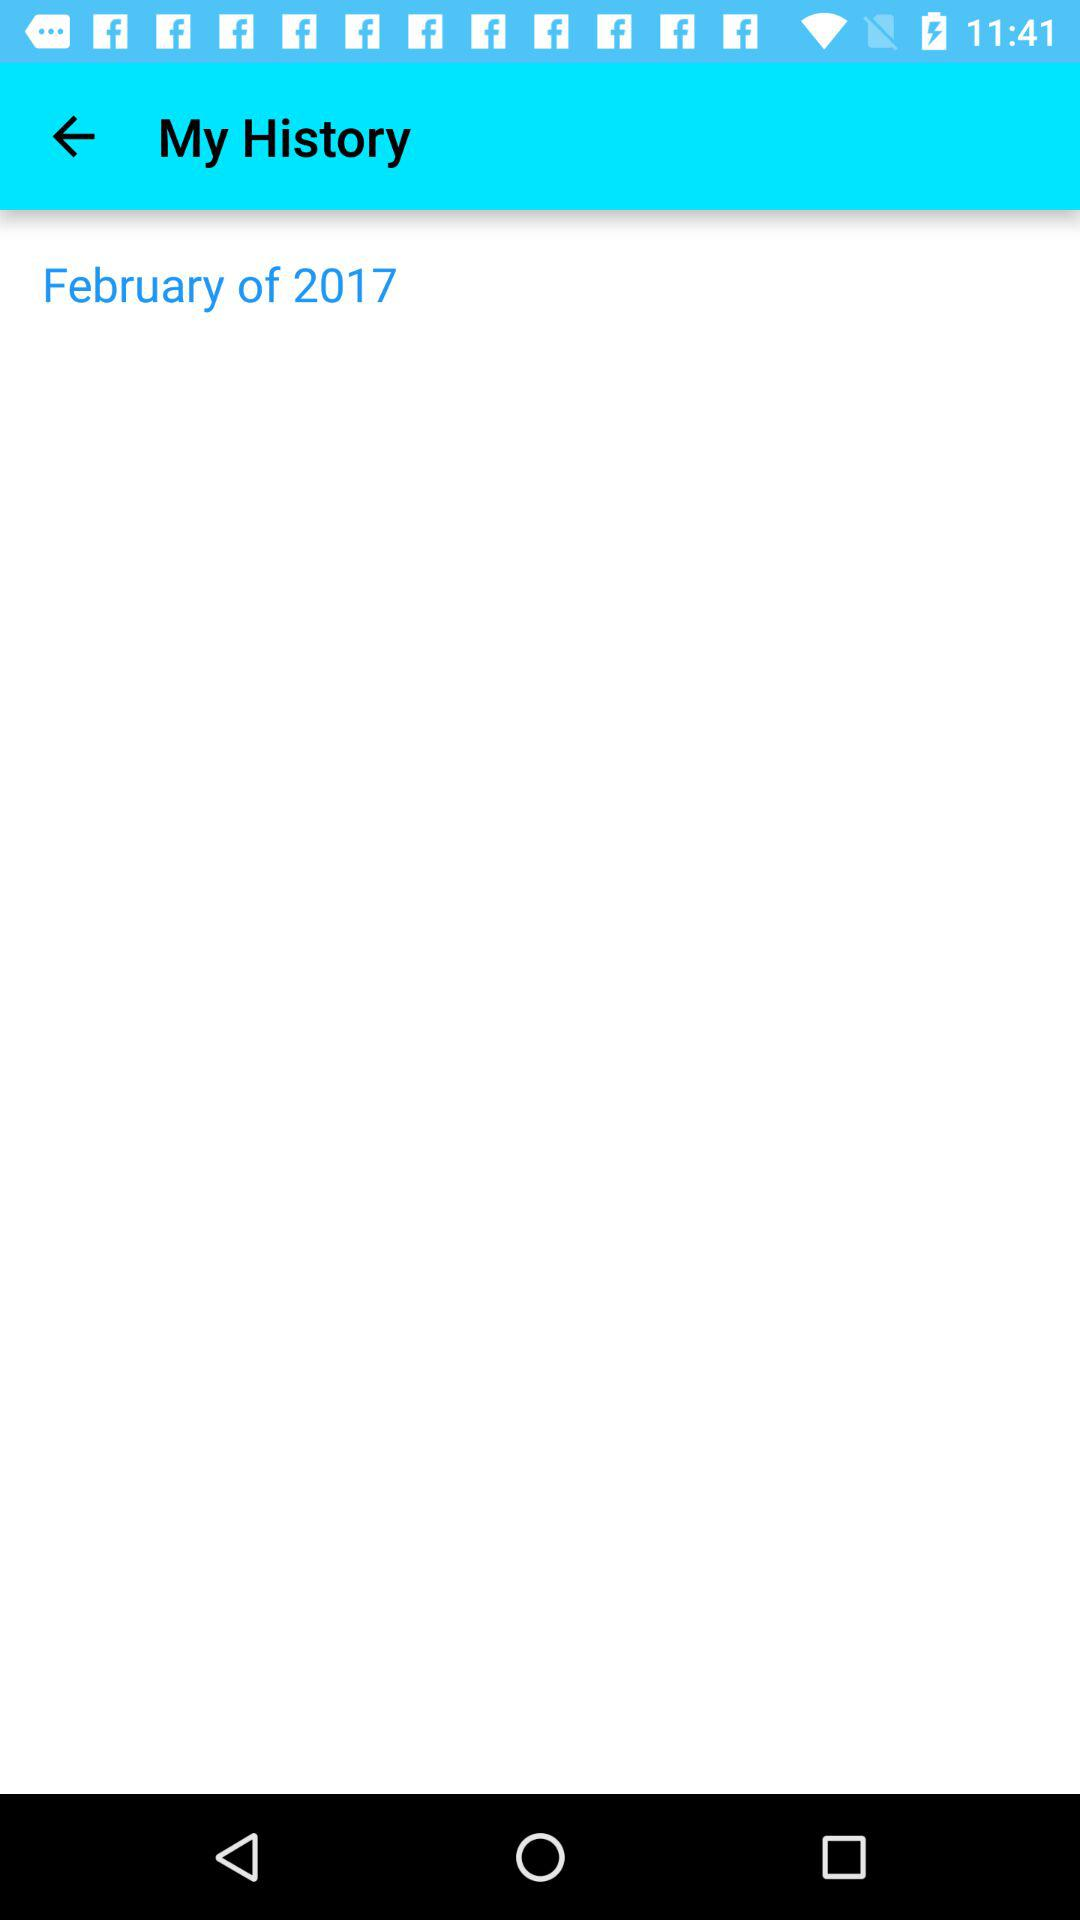What year is mentioned? The mentioned year is 2017. 